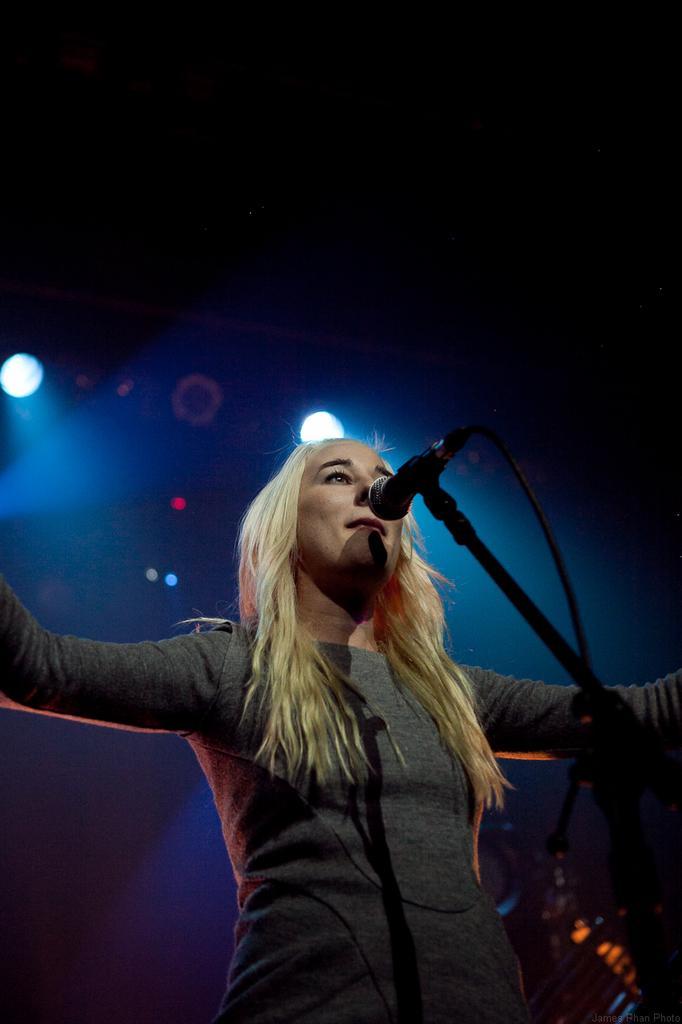Describe this image in one or two sentences. In this image I can see a woman wearing grey colored dress is standing and I can see a microphone in front of her. I can see few lights and the dark background. 